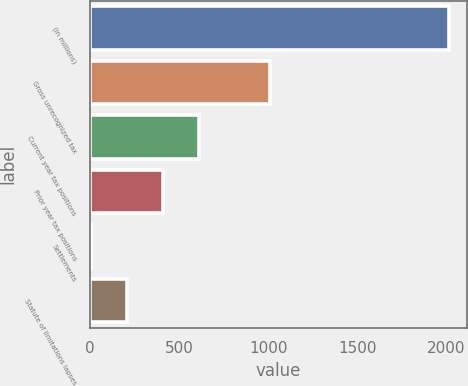<chart> <loc_0><loc_0><loc_500><loc_500><bar_chart><fcel>(in millions)<fcel>Gross unrecognized tax<fcel>Current year tax positions<fcel>Prior year tax positions<fcel>Settlements<fcel>Statute of limitations lapses<nl><fcel>2016<fcel>1011<fcel>609<fcel>408<fcel>6<fcel>207<nl></chart> 